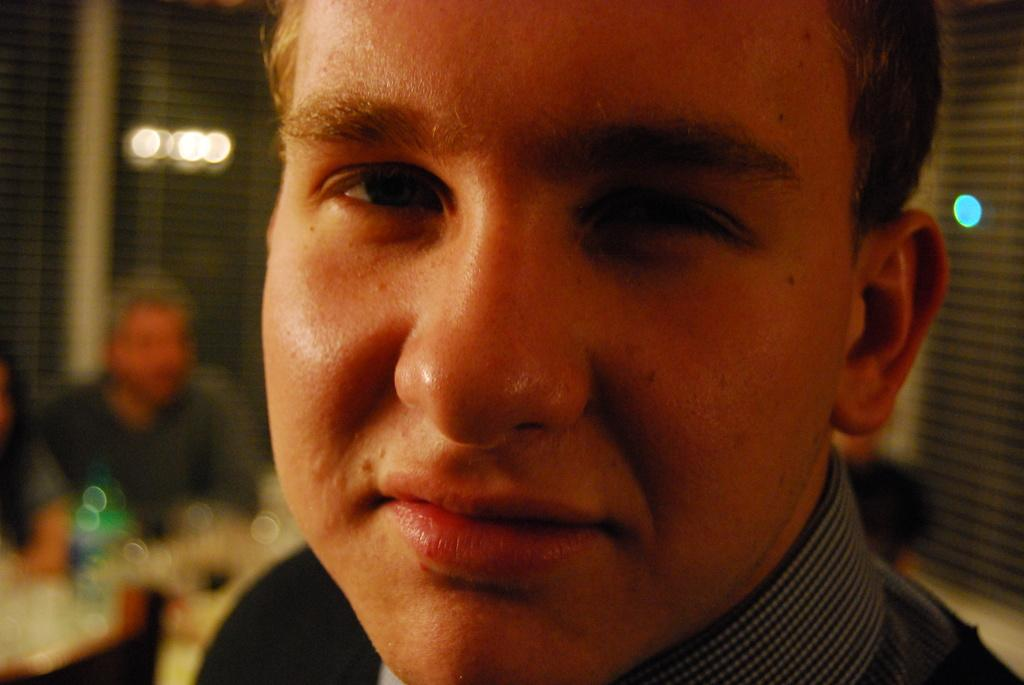Who is the main subject in the front of the image? There is a person in the front of the image. What are the people behind the person doing? The people sitting on chairs behind the person are likely observing or interacting with the person in the front. What can be seen at the back of the image? There are lights visible at the backside of the image. How many friends are walking down the alley in the image? There is no alley or friends present in the image. 